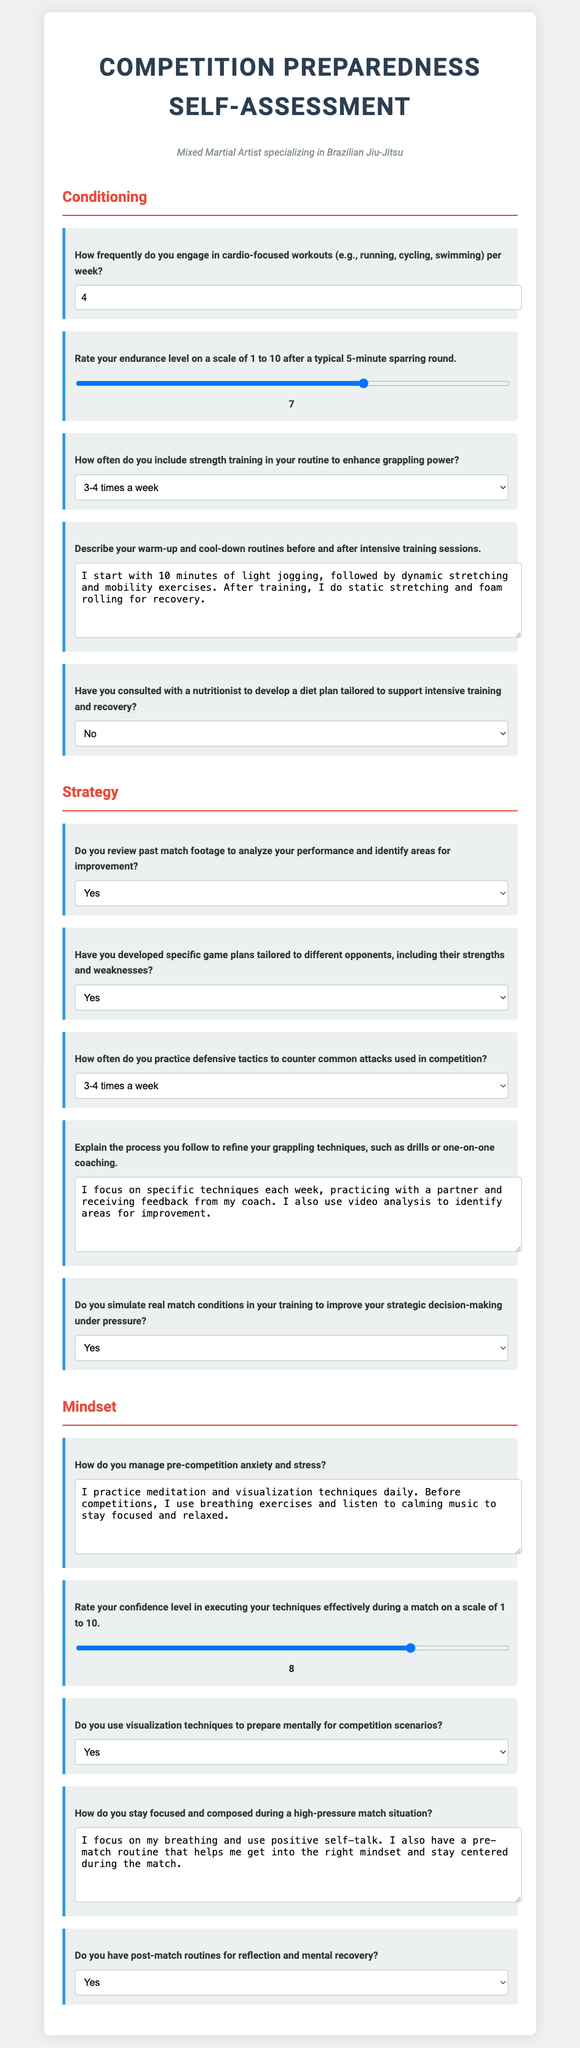How many cardio-focused workouts do you engage in per week? The document states that the frequency can be between 0 to 7, and the selected value is 4.
Answer: 4 What is your endurance level after a typical 5-minute sparring round? The endurance level is rated on a scale of 1 to 10, with the selected value being 7.
Answer: 7 How often do you include strength training to enhance grappling power? The options include various frequencies, with the selected option being "3-4 times a week."
Answer: 3-4 times a week Do you review past match footage? The document presents a yes/no question and the selected answer is "Yes."
Answer: Yes What techniques do you use to manage pre-competition anxiety? The document includes a description of anxiety management techniques including meditation and breathing exercises.
Answer: Meditation and breathing exercises 